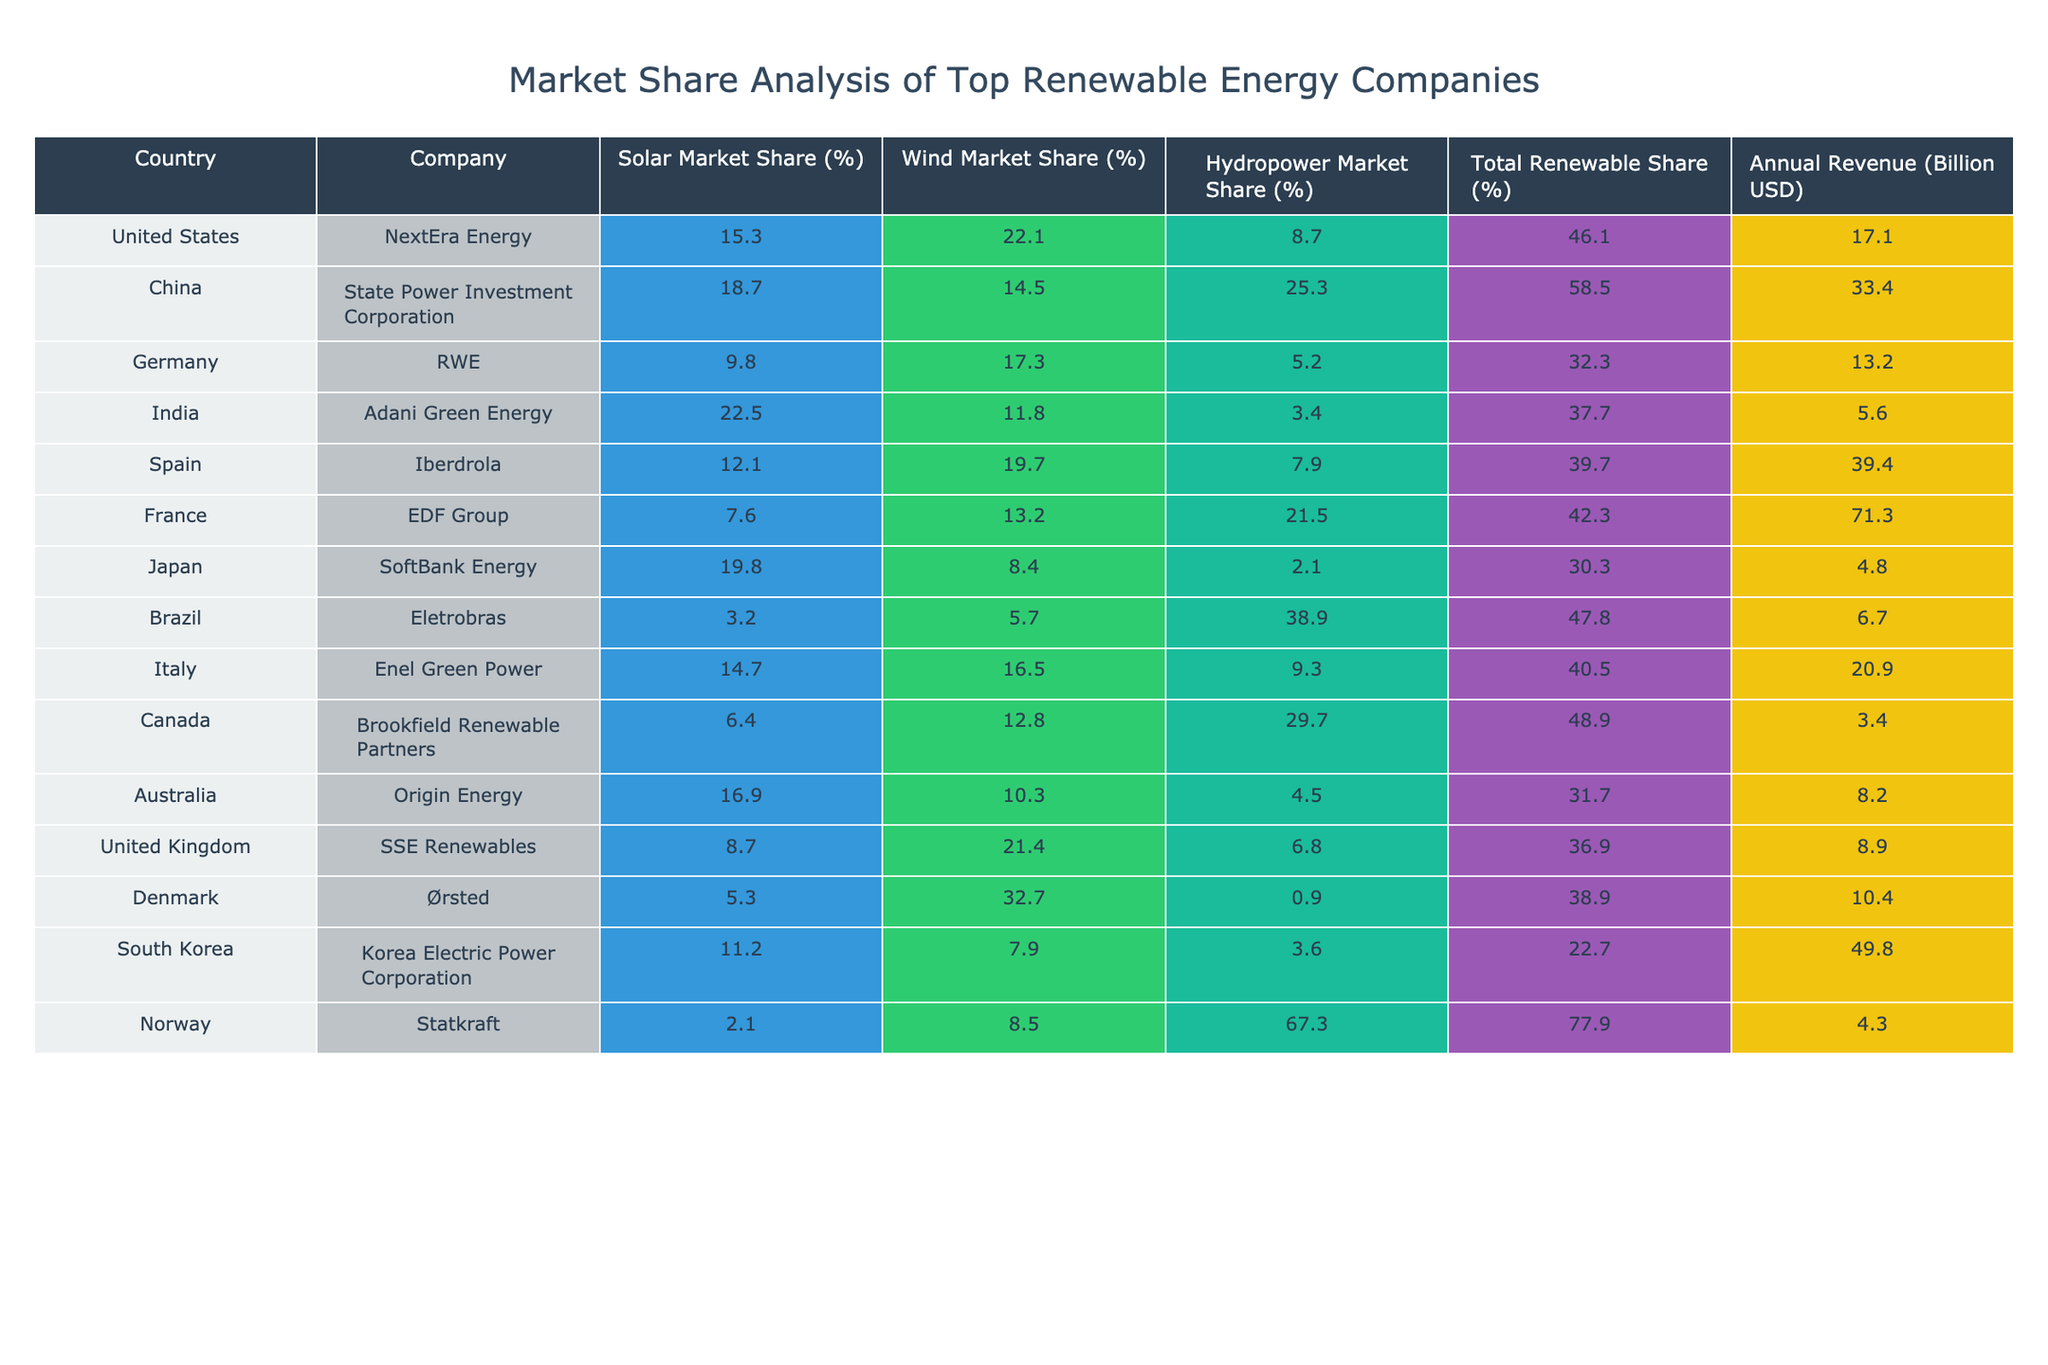What is the solar market share percentage of Adani Green Energy in India? The table lists Adani Green Energy under India with a solar market share of 22.5%.
Answer: 22.5% Which company has the highest total renewable share among the listed countries? By comparing the Total Renewable Share column, EDF Group from France has the highest total renewable share at 42.3%.
Answer: EDF Group (France) What is the annual revenue of State Power Investment Corporation in China? Referring to the table, State Power Investment Corporation has an annual revenue of 33.4 billion USD.
Answer: 33.4 billion USD What is the difference in solar market share between NextEra Energy and SoftBank Energy? NextEra Energy has a solar market share of 15.3% and SoftBank Energy has 19.8%. The difference is calculated by subtracting: 19.8% - 15.3% = 4.5%.
Answer: 4.5% Is the wind market share of Ørsted greater than or equal to 30%? Ørsted has a wind market share of 32.7%, which is greater than 30%.
Answer: Yes What is the average solar market share of the top companies from the United States, Germany, and Canada? The solar market shares are 15.3% (NextEra Energy), 9.8% (RWE), and 6.4% (Brookfield Renewable Partners). Adding these gives 15.3% + 9.8% + 6.4% = 31.5%. There are 3 companies, so the average is 31.5% / 3 = 10.5%.
Answer: 10.5% Which company in Brazil has the lowest solar market share? Eletrobras in Brazil has a solar market share of 3.2%, which is the lowest compared to others in the table.
Answer: Eletrobras If we consider the total renewable share, which company has the lowest overall share? By examining the Total Renewable Share column, Statkraft from Norway has the lowest share at 77.9%.
Answer: Statkraft (Norway) Calculate the total annual revenue of companies with the highest solar market shares. The companies with the highest solar market shares are Adani Green Energy (22.5 billion), SoftBank Energy (19.8 billion), and State Power Investment Corporation (33.4 billion). Adding these gives: 22.5 + 19.8 + 33.4 = 75.7 billion USD.
Answer: 75.7 billion USD What percentage of the hydropower market does the company from Norway control? Statkraft controls 67.3% of the hydropower market, as indicated in the table.
Answer: 67.3% Which country has the highest market share in wind energy, and what is its percentage? By looking at the Wind Market Share column, Denmark (Ørsted) has the highest wind market share with 32.7%.
Answer: Denmark (32.7%) 